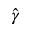<formula> <loc_0><loc_0><loc_500><loc_500>\hat { \gamma }</formula> 